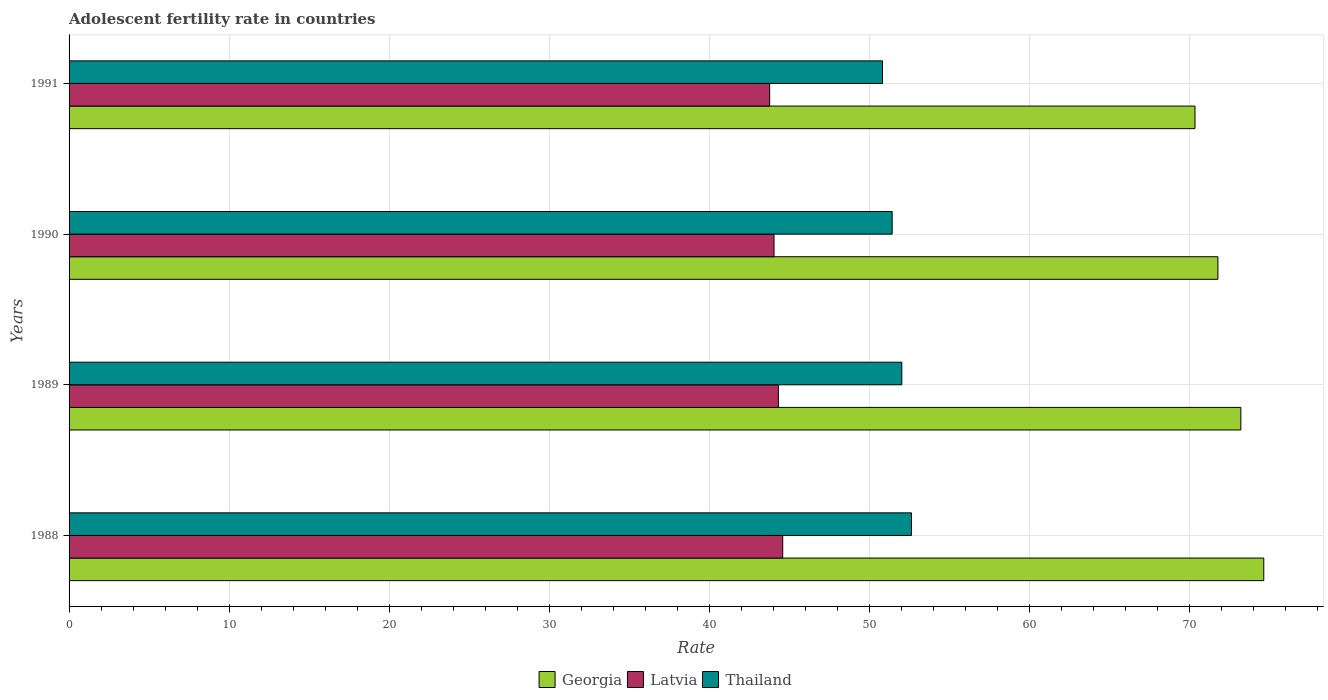Are the number of bars on each tick of the Y-axis equal?
Provide a succinct answer. Yes. How many bars are there on the 2nd tick from the top?
Your answer should be very brief. 3. How many bars are there on the 2nd tick from the bottom?
Your answer should be compact. 3. In how many cases, is the number of bars for a given year not equal to the number of legend labels?
Offer a terse response. 0. What is the adolescent fertility rate in Thailand in 1991?
Provide a succinct answer. 50.83. Across all years, what is the maximum adolescent fertility rate in Latvia?
Offer a terse response. 44.59. Across all years, what is the minimum adolescent fertility rate in Latvia?
Provide a short and direct response. 43.78. In which year was the adolescent fertility rate in Thailand maximum?
Provide a short and direct response. 1988. What is the total adolescent fertility rate in Georgia in the graph?
Your answer should be very brief. 290.01. What is the difference between the adolescent fertility rate in Georgia in 1990 and that in 1991?
Give a very brief answer. 1.43. What is the difference between the adolescent fertility rate in Latvia in 1990 and the adolescent fertility rate in Georgia in 1988?
Offer a terse response. -30.6. What is the average adolescent fertility rate in Georgia per year?
Provide a succinct answer. 72.5. In the year 1989, what is the difference between the adolescent fertility rate in Georgia and adolescent fertility rate in Thailand?
Give a very brief answer. 21.18. In how many years, is the adolescent fertility rate in Thailand greater than 42 ?
Keep it short and to the point. 4. What is the ratio of the adolescent fertility rate in Thailand in 1989 to that in 1990?
Keep it short and to the point. 1.01. Is the difference between the adolescent fertility rate in Georgia in 1990 and 1991 greater than the difference between the adolescent fertility rate in Thailand in 1990 and 1991?
Give a very brief answer. Yes. What is the difference between the highest and the second highest adolescent fertility rate in Latvia?
Your answer should be compact. 0.27. What is the difference between the highest and the lowest adolescent fertility rate in Latvia?
Ensure brevity in your answer.  0.82. In how many years, is the adolescent fertility rate in Thailand greater than the average adolescent fertility rate in Thailand taken over all years?
Your answer should be compact. 2. Is the sum of the adolescent fertility rate in Thailand in 1988 and 1990 greater than the maximum adolescent fertility rate in Georgia across all years?
Provide a succinct answer. Yes. What does the 2nd bar from the top in 1989 represents?
Your answer should be compact. Latvia. What does the 1st bar from the bottom in 1990 represents?
Make the answer very short. Georgia. Is it the case that in every year, the sum of the adolescent fertility rate in Georgia and adolescent fertility rate in Latvia is greater than the adolescent fertility rate in Thailand?
Ensure brevity in your answer.  Yes. How many years are there in the graph?
Offer a very short reply. 4. Does the graph contain grids?
Provide a succinct answer. Yes. Where does the legend appear in the graph?
Make the answer very short. Bottom center. How many legend labels are there?
Provide a short and direct response. 3. What is the title of the graph?
Keep it short and to the point. Adolescent fertility rate in countries. Does "Belize" appear as one of the legend labels in the graph?
Offer a very short reply. No. What is the label or title of the X-axis?
Your answer should be very brief. Rate. What is the label or title of the Y-axis?
Keep it short and to the point. Years. What is the Rate of Georgia in 1988?
Your answer should be very brief. 74.65. What is the Rate in Latvia in 1988?
Make the answer very short. 44.59. What is the Rate in Thailand in 1988?
Your response must be concise. 52.64. What is the Rate of Georgia in 1989?
Ensure brevity in your answer.  73.22. What is the Rate of Latvia in 1989?
Provide a succinct answer. 44.32. What is the Rate of Thailand in 1989?
Your answer should be very brief. 52.03. What is the Rate of Georgia in 1990?
Your answer should be compact. 71.79. What is the Rate in Latvia in 1990?
Offer a very short reply. 44.05. What is the Rate in Thailand in 1990?
Provide a succinct answer. 51.43. What is the Rate of Georgia in 1991?
Provide a short and direct response. 70.35. What is the Rate of Latvia in 1991?
Ensure brevity in your answer.  43.78. What is the Rate of Thailand in 1991?
Your response must be concise. 50.83. Across all years, what is the maximum Rate of Georgia?
Provide a succinct answer. 74.65. Across all years, what is the maximum Rate of Latvia?
Provide a succinct answer. 44.59. Across all years, what is the maximum Rate of Thailand?
Offer a very short reply. 52.64. Across all years, what is the minimum Rate of Georgia?
Make the answer very short. 70.35. Across all years, what is the minimum Rate in Latvia?
Give a very brief answer. 43.78. Across all years, what is the minimum Rate in Thailand?
Give a very brief answer. 50.83. What is the total Rate in Georgia in the graph?
Offer a terse response. 290.01. What is the total Rate in Latvia in the graph?
Offer a very short reply. 176.74. What is the total Rate in Thailand in the graph?
Keep it short and to the point. 206.93. What is the difference between the Rate of Georgia in 1988 and that in 1989?
Give a very brief answer. 1.43. What is the difference between the Rate in Latvia in 1988 and that in 1989?
Offer a terse response. 0.27. What is the difference between the Rate of Thailand in 1988 and that in 1989?
Offer a terse response. 0.6. What is the difference between the Rate in Georgia in 1988 and that in 1990?
Make the answer very short. 2.86. What is the difference between the Rate of Latvia in 1988 and that in 1990?
Ensure brevity in your answer.  0.54. What is the difference between the Rate of Thailand in 1988 and that in 1990?
Provide a succinct answer. 1.21. What is the difference between the Rate in Georgia in 1988 and that in 1991?
Keep it short and to the point. 4.3. What is the difference between the Rate in Latvia in 1988 and that in 1991?
Make the answer very short. 0.82. What is the difference between the Rate of Thailand in 1988 and that in 1991?
Your answer should be very brief. 1.81. What is the difference between the Rate in Georgia in 1989 and that in 1990?
Offer a terse response. 1.43. What is the difference between the Rate of Latvia in 1989 and that in 1990?
Offer a very short reply. 0.27. What is the difference between the Rate in Thailand in 1989 and that in 1990?
Ensure brevity in your answer.  0.6. What is the difference between the Rate in Georgia in 1989 and that in 1991?
Ensure brevity in your answer.  2.86. What is the difference between the Rate of Latvia in 1989 and that in 1991?
Provide a short and direct response. 0.54. What is the difference between the Rate in Thailand in 1989 and that in 1991?
Your answer should be compact. 1.21. What is the difference between the Rate in Georgia in 1990 and that in 1991?
Provide a succinct answer. 1.43. What is the difference between the Rate of Latvia in 1990 and that in 1991?
Keep it short and to the point. 0.27. What is the difference between the Rate in Thailand in 1990 and that in 1991?
Offer a terse response. 0.6. What is the difference between the Rate in Georgia in 1988 and the Rate in Latvia in 1989?
Give a very brief answer. 30.33. What is the difference between the Rate in Georgia in 1988 and the Rate in Thailand in 1989?
Offer a terse response. 22.62. What is the difference between the Rate in Latvia in 1988 and the Rate in Thailand in 1989?
Ensure brevity in your answer.  -7.44. What is the difference between the Rate of Georgia in 1988 and the Rate of Latvia in 1990?
Offer a very short reply. 30.6. What is the difference between the Rate in Georgia in 1988 and the Rate in Thailand in 1990?
Make the answer very short. 23.22. What is the difference between the Rate of Latvia in 1988 and the Rate of Thailand in 1990?
Offer a very short reply. -6.84. What is the difference between the Rate in Georgia in 1988 and the Rate in Latvia in 1991?
Your answer should be compact. 30.87. What is the difference between the Rate in Georgia in 1988 and the Rate in Thailand in 1991?
Offer a very short reply. 23.82. What is the difference between the Rate in Latvia in 1988 and the Rate in Thailand in 1991?
Make the answer very short. -6.24. What is the difference between the Rate of Georgia in 1989 and the Rate of Latvia in 1990?
Ensure brevity in your answer.  29.17. What is the difference between the Rate of Georgia in 1989 and the Rate of Thailand in 1990?
Make the answer very short. 21.79. What is the difference between the Rate in Latvia in 1989 and the Rate in Thailand in 1990?
Provide a short and direct response. -7.11. What is the difference between the Rate of Georgia in 1989 and the Rate of Latvia in 1991?
Your answer should be very brief. 29.44. What is the difference between the Rate of Georgia in 1989 and the Rate of Thailand in 1991?
Provide a short and direct response. 22.39. What is the difference between the Rate of Latvia in 1989 and the Rate of Thailand in 1991?
Provide a short and direct response. -6.51. What is the difference between the Rate of Georgia in 1990 and the Rate of Latvia in 1991?
Make the answer very short. 28.01. What is the difference between the Rate in Georgia in 1990 and the Rate in Thailand in 1991?
Offer a terse response. 20.96. What is the difference between the Rate in Latvia in 1990 and the Rate in Thailand in 1991?
Offer a terse response. -6.78. What is the average Rate of Georgia per year?
Provide a succinct answer. 72.5. What is the average Rate in Latvia per year?
Make the answer very short. 44.18. What is the average Rate of Thailand per year?
Provide a succinct answer. 51.73. In the year 1988, what is the difference between the Rate of Georgia and Rate of Latvia?
Keep it short and to the point. 30.06. In the year 1988, what is the difference between the Rate in Georgia and Rate in Thailand?
Give a very brief answer. 22.01. In the year 1988, what is the difference between the Rate in Latvia and Rate in Thailand?
Provide a succinct answer. -8.04. In the year 1989, what is the difference between the Rate of Georgia and Rate of Latvia?
Make the answer very short. 28.9. In the year 1989, what is the difference between the Rate in Georgia and Rate in Thailand?
Make the answer very short. 21.18. In the year 1989, what is the difference between the Rate of Latvia and Rate of Thailand?
Your response must be concise. -7.71. In the year 1990, what is the difference between the Rate of Georgia and Rate of Latvia?
Ensure brevity in your answer.  27.74. In the year 1990, what is the difference between the Rate of Georgia and Rate of Thailand?
Your answer should be very brief. 20.35. In the year 1990, what is the difference between the Rate in Latvia and Rate in Thailand?
Provide a short and direct response. -7.38. In the year 1991, what is the difference between the Rate in Georgia and Rate in Latvia?
Offer a terse response. 26.58. In the year 1991, what is the difference between the Rate of Georgia and Rate of Thailand?
Your answer should be very brief. 19.53. In the year 1991, what is the difference between the Rate in Latvia and Rate in Thailand?
Your response must be concise. -7.05. What is the ratio of the Rate in Georgia in 1988 to that in 1989?
Your answer should be very brief. 1.02. What is the ratio of the Rate of Latvia in 1988 to that in 1989?
Keep it short and to the point. 1.01. What is the ratio of the Rate of Thailand in 1988 to that in 1989?
Your answer should be compact. 1.01. What is the ratio of the Rate of Georgia in 1988 to that in 1990?
Provide a short and direct response. 1.04. What is the ratio of the Rate of Latvia in 1988 to that in 1990?
Your answer should be compact. 1.01. What is the ratio of the Rate of Thailand in 1988 to that in 1990?
Give a very brief answer. 1.02. What is the ratio of the Rate in Georgia in 1988 to that in 1991?
Make the answer very short. 1.06. What is the ratio of the Rate of Latvia in 1988 to that in 1991?
Your answer should be compact. 1.02. What is the ratio of the Rate of Thailand in 1988 to that in 1991?
Make the answer very short. 1.04. What is the ratio of the Rate in Georgia in 1989 to that in 1990?
Offer a very short reply. 1.02. What is the ratio of the Rate in Latvia in 1989 to that in 1990?
Your answer should be compact. 1.01. What is the ratio of the Rate of Thailand in 1989 to that in 1990?
Your response must be concise. 1.01. What is the ratio of the Rate of Georgia in 1989 to that in 1991?
Ensure brevity in your answer.  1.04. What is the ratio of the Rate in Latvia in 1989 to that in 1991?
Keep it short and to the point. 1.01. What is the ratio of the Rate of Thailand in 1989 to that in 1991?
Provide a short and direct response. 1.02. What is the ratio of the Rate in Georgia in 1990 to that in 1991?
Your response must be concise. 1.02. What is the ratio of the Rate in Thailand in 1990 to that in 1991?
Ensure brevity in your answer.  1.01. What is the difference between the highest and the second highest Rate of Georgia?
Your answer should be very brief. 1.43. What is the difference between the highest and the second highest Rate of Latvia?
Make the answer very short. 0.27. What is the difference between the highest and the second highest Rate of Thailand?
Provide a succinct answer. 0.6. What is the difference between the highest and the lowest Rate in Georgia?
Your response must be concise. 4.3. What is the difference between the highest and the lowest Rate of Latvia?
Make the answer very short. 0.82. What is the difference between the highest and the lowest Rate in Thailand?
Ensure brevity in your answer.  1.81. 